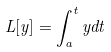<formula> <loc_0><loc_0><loc_500><loc_500>L [ y ] = \int _ { a } ^ { t } y d t</formula> 